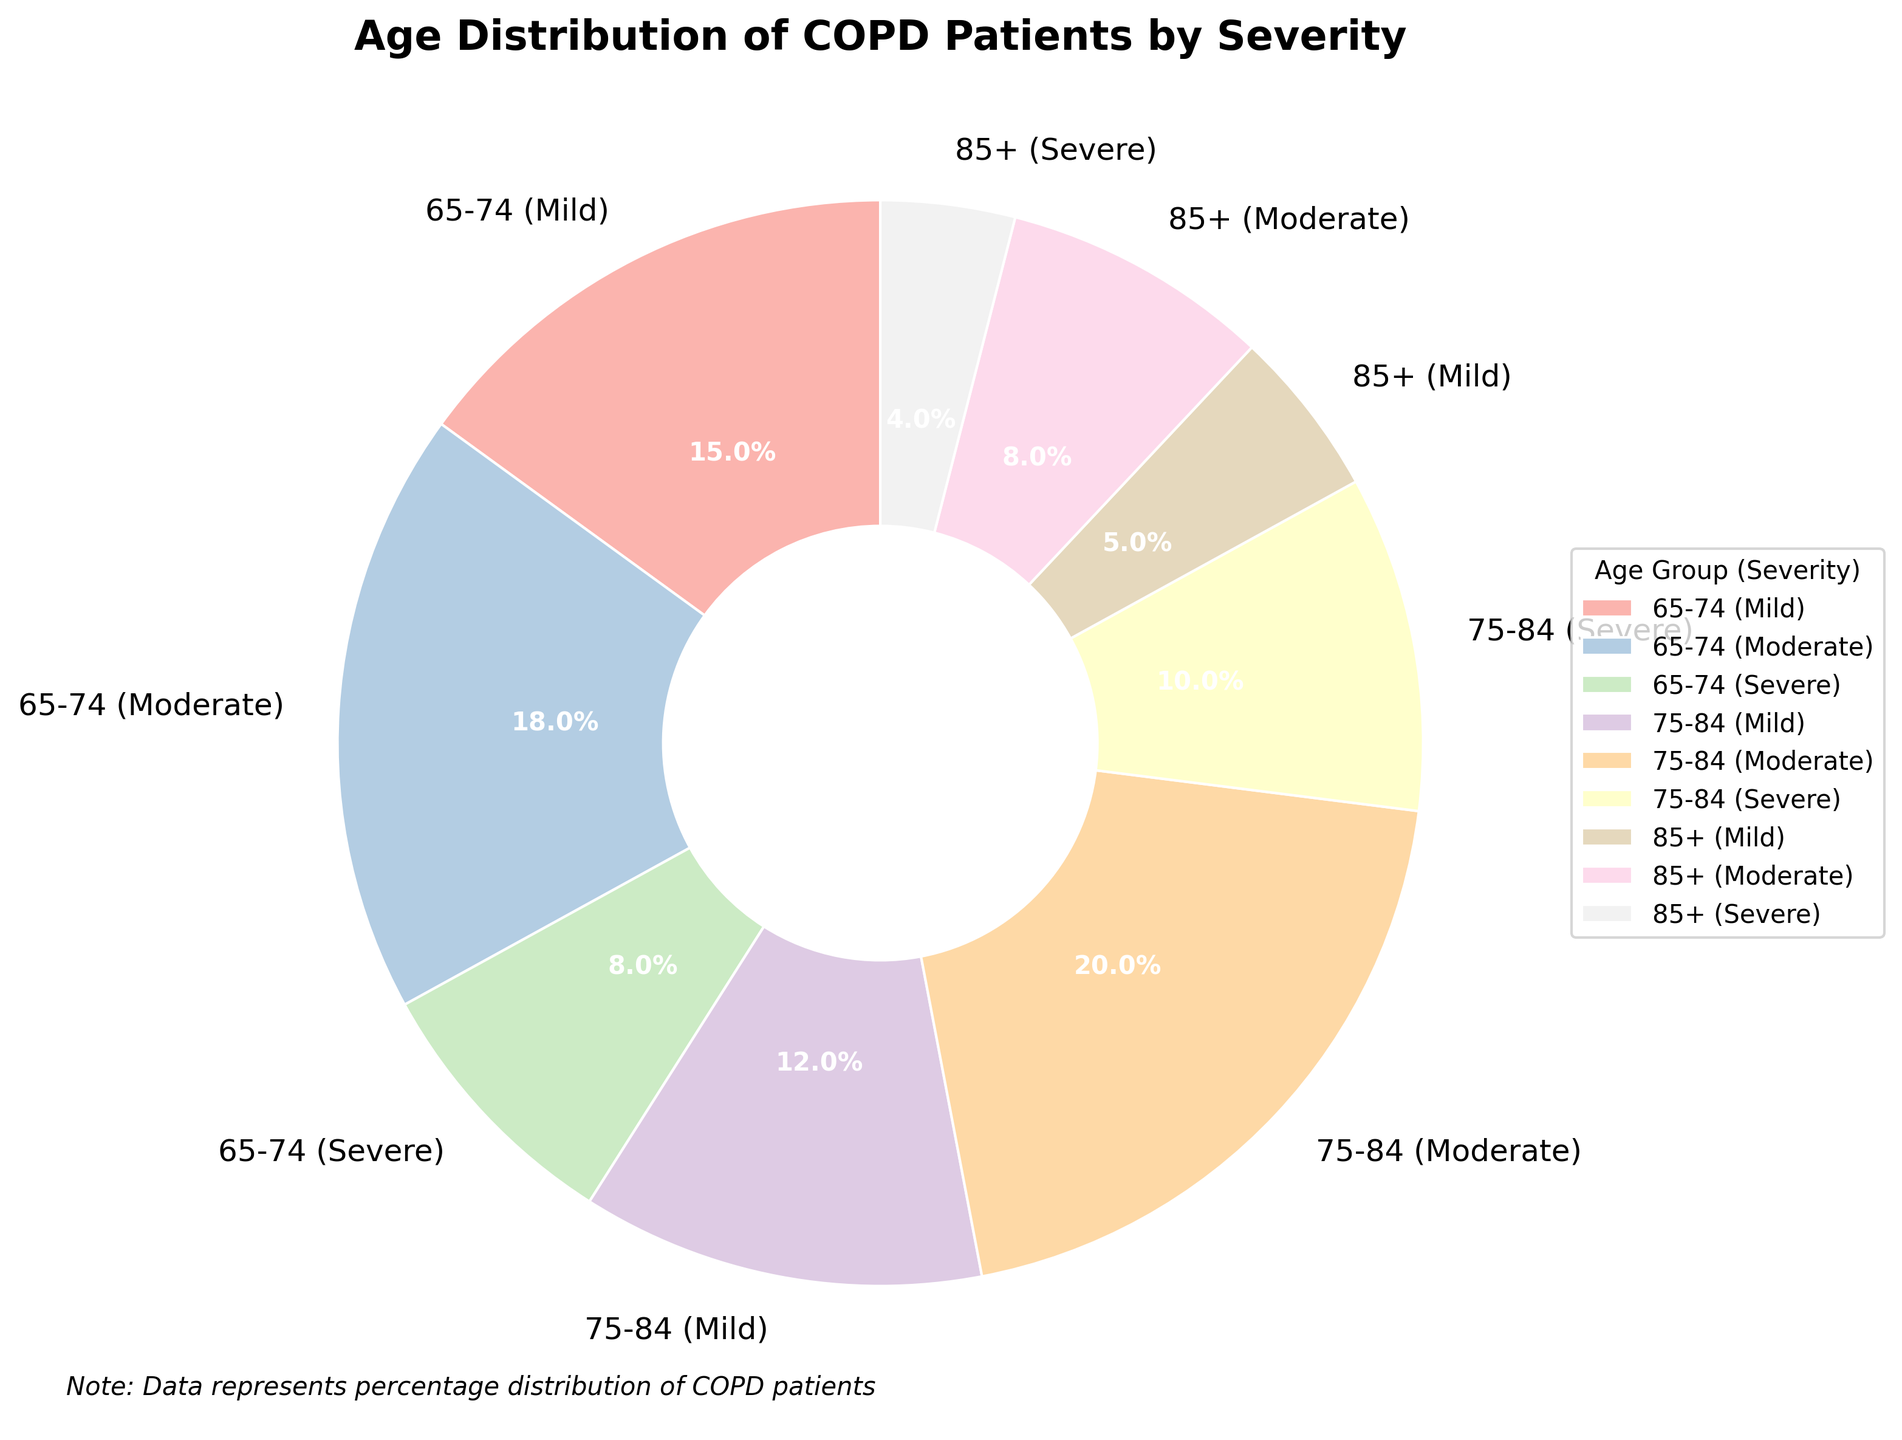What's the total percentage of COPD patients aged 75-84 across all severities? Add the percentages of Mild, Moderate, and Severe in the 75-84 age group: 12% (Mild) + 20% (Moderate) + 10% (Severe) = 42%
Answer: 42% Which severity level has the highest percentage among COPD patients aged 65-74? Compare the percentages for Mild (15%), Moderate (18%), and Severe (8%) in the 65-74 age group. Moderate is the highest at 18%
Answer: Moderate What is the total percentage of Severe COPD patients across all age groups? Add the percentages of Severe COPD patients: 8% (65-74) + 10% (75-84) + 4% (85+) = 22%
Answer: 22% Which age group has the lowest percentage of Mild COPD patients? Compare the percentages of Mild COPD patients in 65-74 (15%), 75-84 (12%), and 85+ (5%). The lowest is 85+ at 5%
Answer: 85+ Is the percentage of Moderate COPD patients aged 75-84 greater than the percentage of Severe COPD patients in the same age group? Compare Moderate (20%) and Severe (10%) COPD percentages in 75-84. 20% is greater than 10%
Answer: Yes What's the combined percentage of Mild and Severe COPD patients aged 65-74? Sum the percentages of Mild and Severe COPD patients in 65-74: 15% (Mild) + 8% (Severe) = 23%
Answer: 23% Which age group has the highest overall percentage of COPD patients? Sum the percentages for each age group and compare:
- 65-74: 15% + 18% + 8% = 41%
- 75-84: 12% + 20% + 10% = 42%
- 85+: 5% + 8% + 4% = 17%
75-84 has the highest overall percentage at 42%
Answer: 75-84 What is the difference in percentage between Severe and Moderate COPD patients aged 85+? Find the difference in percentages for Severe (4%) and Moderate (8%) COPD patients in 85+: 8% - 4% = 4%
Answer: 4% Which severity level has the least percentage of COPD patients in the 85+ age group? Compare the percentages of Mild (5%), Moderate (8%), and Severe (4%) in 85+. Severe has the least at 4%
Answer: Severe 